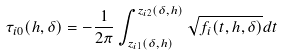<formula> <loc_0><loc_0><loc_500><loc_500>\tau _ { i 0 } ( h , \delta ) = - \frac { 1 } { 2 \pi } \int _ { z _ { i 1 } ( \delta , h ) } ^ { z _ { i 2 } ( \delta , h ) } \sqrt { f _ { i } ( t , h , \delta ) } d t</formula> 